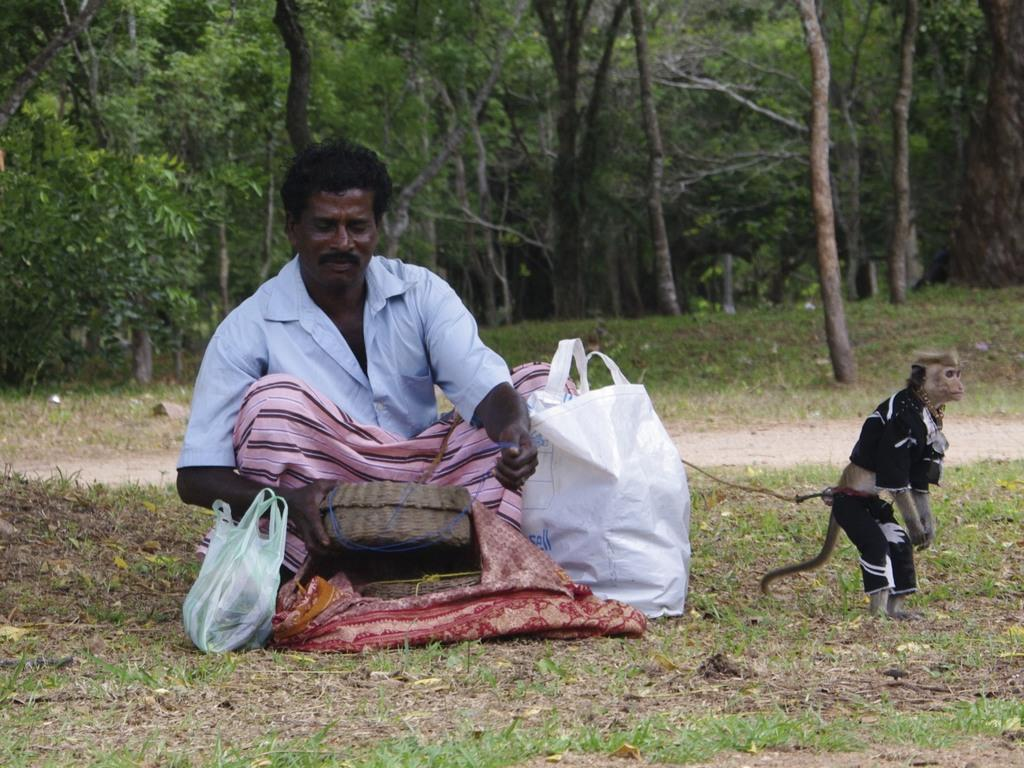What is the person in the image doing? The person is sitting in the image. What is the person holding in the image? The person is holding a basket. What can be seen on the right side of the image? There is a monkey on the right side of the image. What is the monkey wearing in the image? The monkey is wearing a dress. What type of material is present in the image? There are polythene covers in the image. What is visible in the background of the image? There are trees visible in the background of the image. What news is the person reading in the image? There is no newspaper or any indication of news reading in the image. 